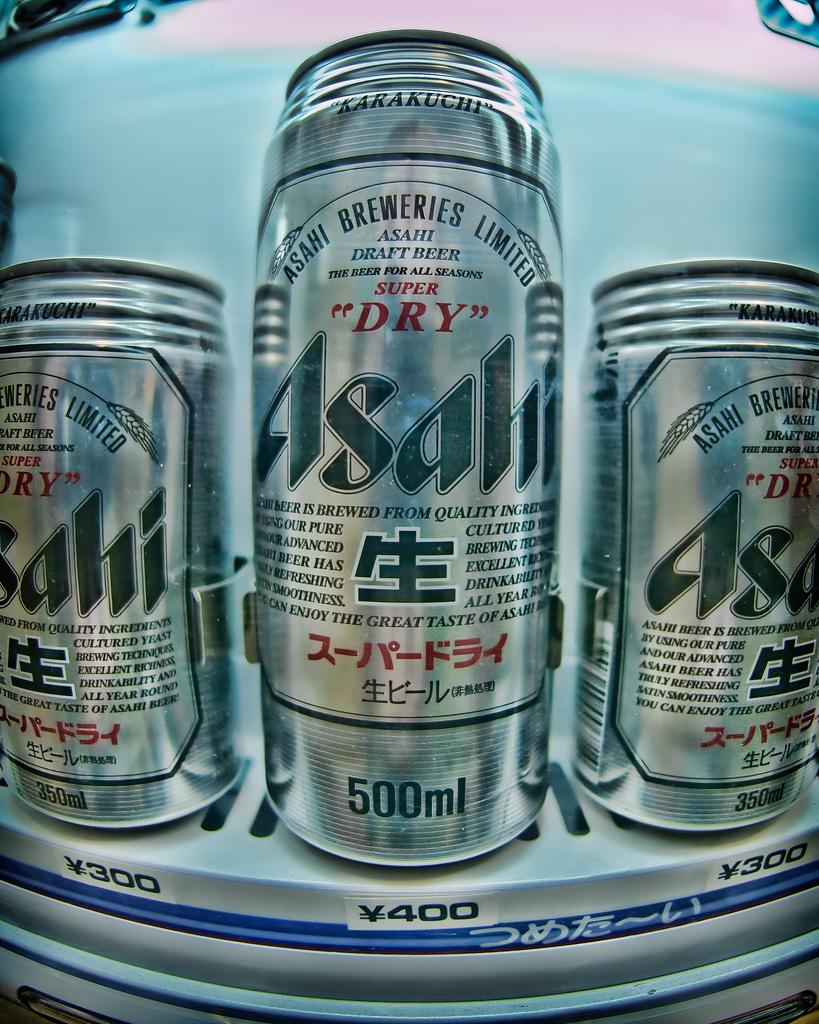What is the brand of beer shown?
Your response must be concise. Asahi. How much volume does the can contain?
Your answer should be compact. 500ml. 